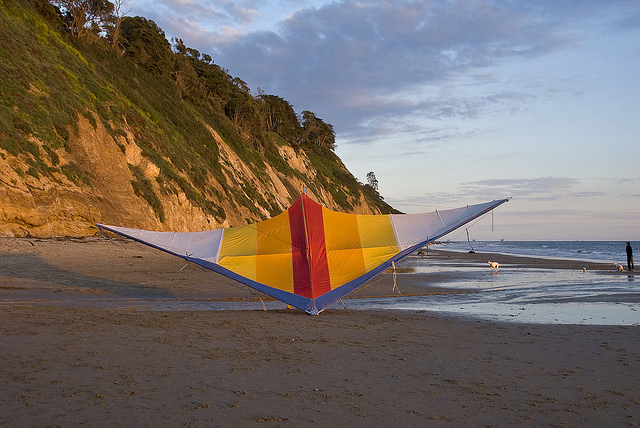How do you think the kite managed to land on the beach? It's likely that the kite was being flown by someone who carefully guided it down to land on the beach. Depending on the wind conditions, kites often require skillful handling to bring them down smoothly without causing damage. The kite now rests gently on the sand, possibly awaiting its next flight. What can be inferred about the wind conditions based on the kite's position? Given that the kite is currently resting on the ground, it can be inferred that the wind might be calm or not strong enough to keep it airborne. Alternatively, it could also indicate that it was intentionally brought down, possibly due to the end of the kite-flying session or for a break. Imagine a scenario where the kite becomes alive. What adventures would it have? Imagine the kite springs to life, fluttering its vibrant wings with newfound freedom. It dances in the breeze, soaring over the ocean, exploring the cliffs, and playing with seagulls. Each gust of wind brings a new adventure as the kite loops and dives, painting the sky with its colorful trail. As evening approaches, it navigates through a maze of stars, embracing the thrill of the night sky, discovering constellations, and befriending nocturnal birds. The living kite experiences a world boundless by the horizon, where every flight is a journey, and every breeze is a story waiting to unfold. 